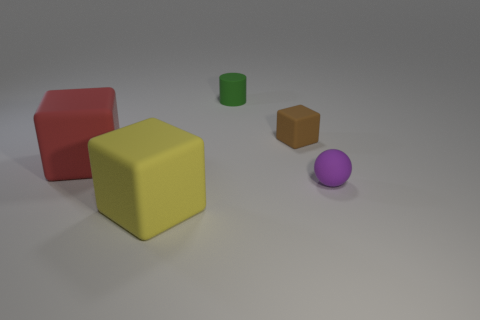Subtract all brown rubber cubes. How many cubes are left? 2 Add 1 big red matte objects. How many objects exist? 6 Subtract all balls. How many objects are left? 4 Subtract all cyan cubes. Subtract all blue cylinders. How many cubes are left? 3 Subtract 0 yellow cylinders. How many objects are left? 5 Subtract all cyan shiny cubes. Subtract all spheres. How many objects are left? 4 Add 3 matte things. How many matte things are left? 8 Add 2 small red matte cubes. How many small red matte cubes exist? 2 